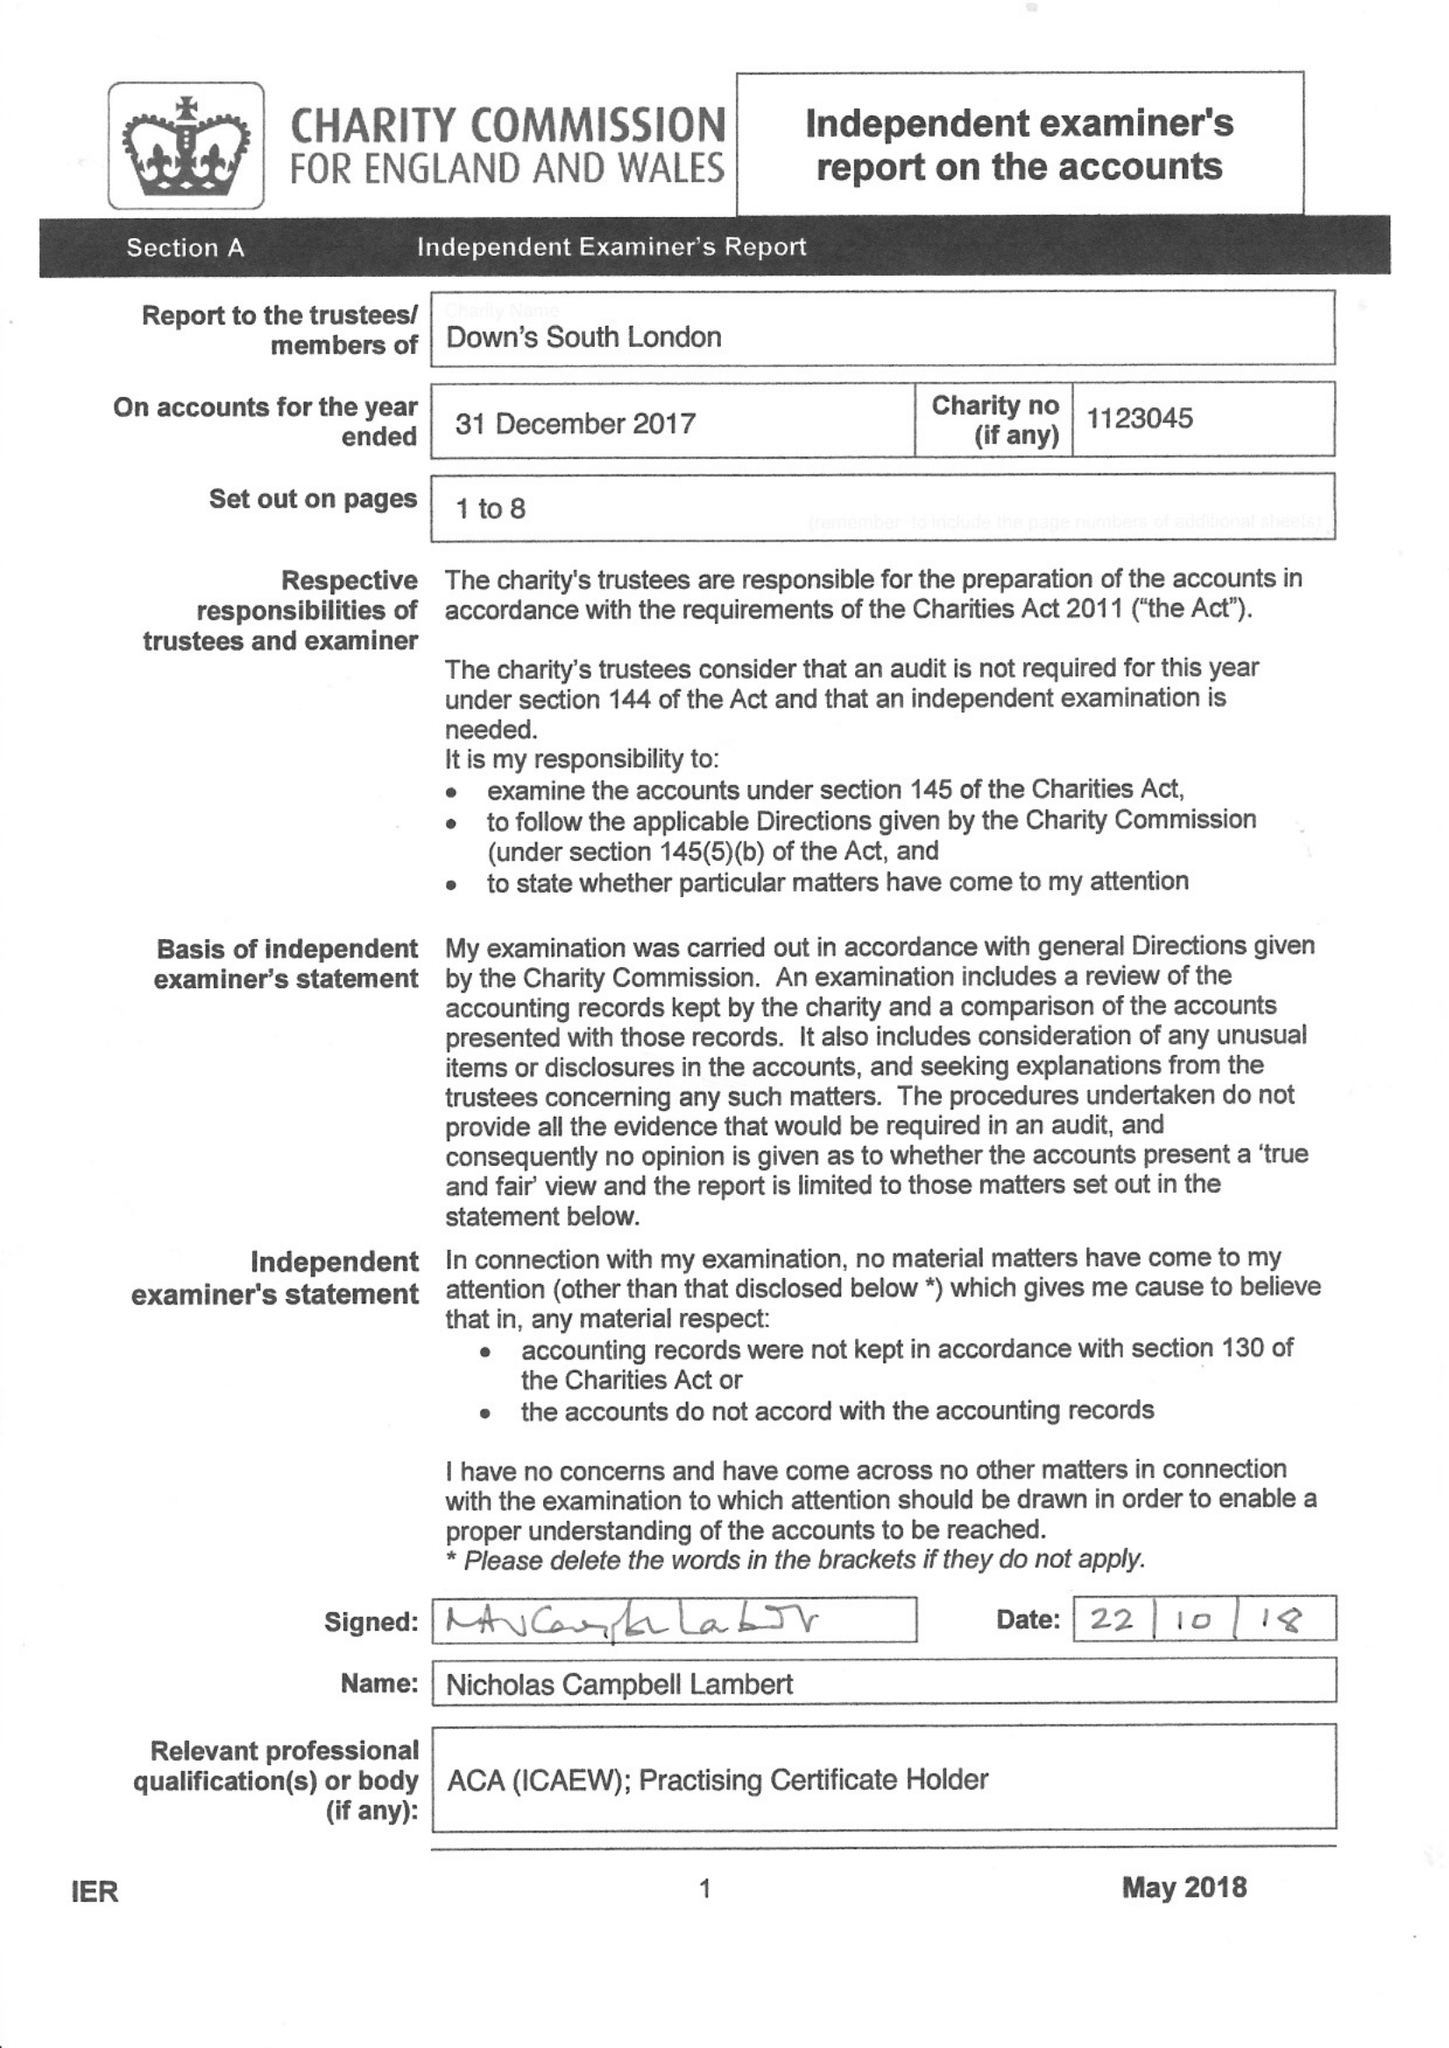What is the value for the address__post_town?
Answer the question using a single word or phrase. LONDON 